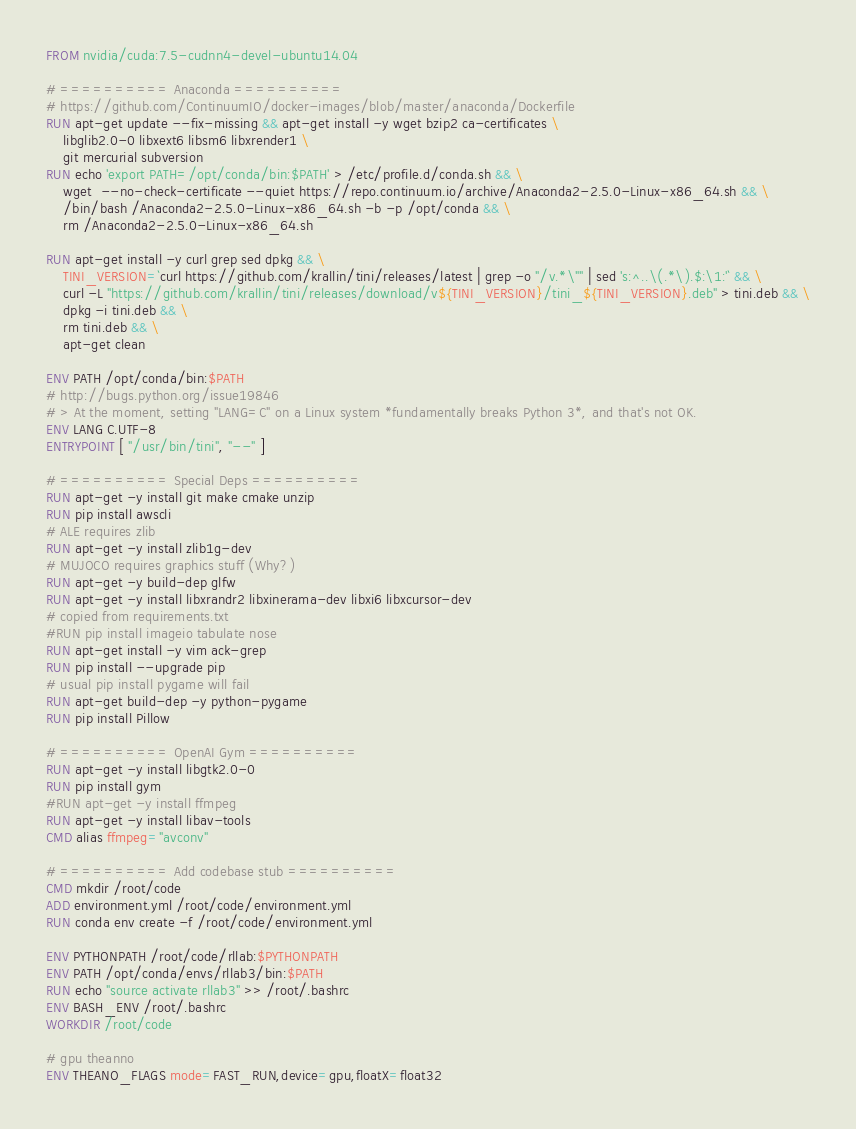<code> <loc_0><loc_0><loc_500><loc_500><_Dockerfile_>FROM nvidia/cuda:7.5-cudnn4-devel-ubuntu14.04

# ========== Anaconda ==========
# https://github.com/ContinuumIO/docker-images/blob/master/anaconda/Dockerfile
RUN apt-get update --fix-missing && apt-get install -y wget bzip2 ca-certificates \
    libglib2.0-0 libxext6 libsm6 libxrender1 \
    git mercurial subversion
RUN echo 'export PATH=/opt/conda/bin:$PATH' > /etc/profile.d/conda.sh && \
    wget  --no-check-certificate --quiet https://repo.continuum.io/archive/Anaconda2-2.5.0-Linux-x86_64.sh && \
    /bin/bash /Anaconda2-2.5.0-Linux-x86_64.sh -b -p /opt/conda && \
    rm /Anaconda2-2.5.0-Linux-x86_64.sh

RUN apt-get install -y curl grep sed dpkg && \
    TINI_VERSION=`curl https://github.com/krallin/tini/releases/latest | grep -o "/v.*\"" | sed 's:^..\(.*\).$:\1:'` && \
    curl -L "https://github.com/krallin/tini/releases/download/v${TINI_VERSION}/tini_${TINI_VERSION}.deb" > tini.deb && \
    dpkg -i tini.deb && \
    rm tini.deb && \
    apt-get clean

ENV PATH /opt/conda/bin:$PATH
# http://bugs.python.org/issue19846
# > At the moment, setting "LANG=C" on a Linux system *fundamentally breaks Python 3*, and that's not OK.
ENV LANG C.UTF-8
ENTRYPOINT [ "/usr/bin/tini", "--" ]

# ========== Special Deps ==========
RUN apt-get -y install git make cmake unzip
RUN pip install awscli
# ALE requires zlib
RUN apt-get -y install zlib1g-dev
# MUJOCO requires graphics stuff (Why?)
RUN apt-get -y build-dep glfw
RUN apt-get -y install libxrandr2 libxinerama-dev libxi6 libxcursor-dev
# copied from requirements.txt
#RUN pip install imageio tabulate nose
RUN apt-get install -y vim ack-grep
RUN pip install --upgrade pip
# usual pip install pygame will fail
RUN apt-get build-dep -y python-pygame
RUN pip install Pillow

# ========== OpenAI Gym ==========
RUN apt-get -y install libgtk2.0-0
RUN pip install gym
#RUN apt-get -y install ffmpeg
RUN apt-get -y install libav-tools
CMD alias ffmpeg="avconv"

# ========== Add codebase stub ==========
CMD mkdir /root/code
ADD environment.yml /root/code/environment.yml
RUN conda env create -f /root/code/environment.yml

ENV PYTHONPATH /root/code/rllab:$PYTHONPATH
ENV PATH /opt/conda/envs/rllab3/bin:$PATH
RUN echo "source activate rllab3" >> /root/.bashrc
ENV BASH_ENV /root/.bashrc
WORKDIR /root/code

# gpu theanno
ENV THEANO_FLAGS mode=FAST_RUN,device=gpu,floatX=float32
</code> 